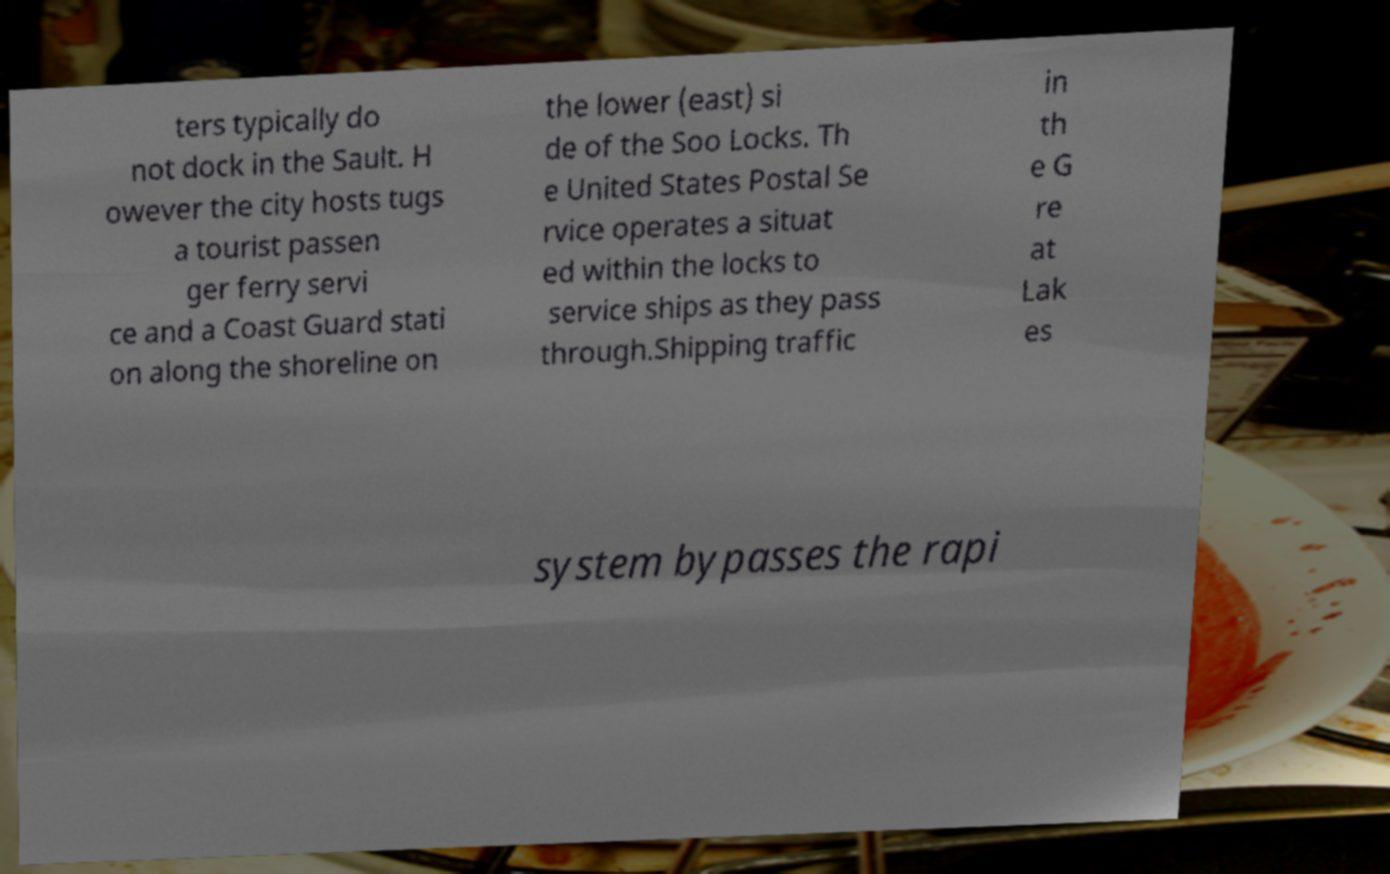What messages or text are displayed in this image? I need them in a readable, typed format. ters typically do not dock in the Sault. H owever the city hosts tugs a tourist passen ger ferry servi ce and a Coast Guard stati on along the shoreline on the lower (east) si de of the Soo Locks. Th e United States Postal Se rvice operates a situat ed within the locks to service ships as they pass through.Shipping traffic in th e G re at Lak es system bypasses the rapi 